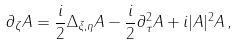Convert formula to latex. <formula><loc_0><loc_0><loc_500><loc_500>\partial _ { \zeta } A = \frac { i } { 2 } \Delta _ { \xi , \eta } A - \frac { i } { 2 } \partial ^ { 2 } _ { \tau } A + i | A | ^ { 2 } A \, ,</formula> 